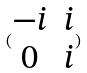Convert formula to latex. <formula><loc_0><loc_0><loc_500><loc_500>( \begin{matrix} - i & i \\ 0 & i \end{matrix} )</formula> 